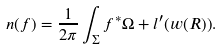<formula> <loc_0><loc_0><loc_500><loc_500>n ( f ) = \frac { 1 } { 2 \pi } \int _ { \Sigma } f ^ { * } \Omega + l ^ { \prime } ( w ( R ) ) .</formula> 